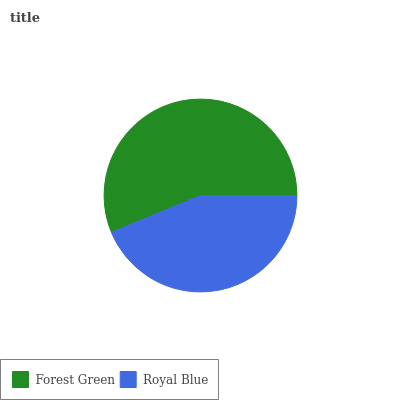Is Royal Blue the minimum?
Answer yes or no. Yes. Is Forest Green the maximum?
Answer yes or no. Yes. Is Royal Blue the maximum?
Answer yes or no. No. Is Forest Green greater than Royal Blue?
Answer yes or no. Yes. Is Royal Blue less than Forest Green?
Answer yes or no. Yes. Is Royal Blue greater than Forest Green?
Answer yes or no. No. Is Forest Green less than Royal Blue?
Answer yes or no. No. Is Forest Green the high median?
Answer yes or no. Yes. Is Royal Blue the low median?
Answer yes or no. Yes. Is Royal Blue the high median?
Answer yes or no. No. Is Forest Green the low median?
Answer yes or no. No. 